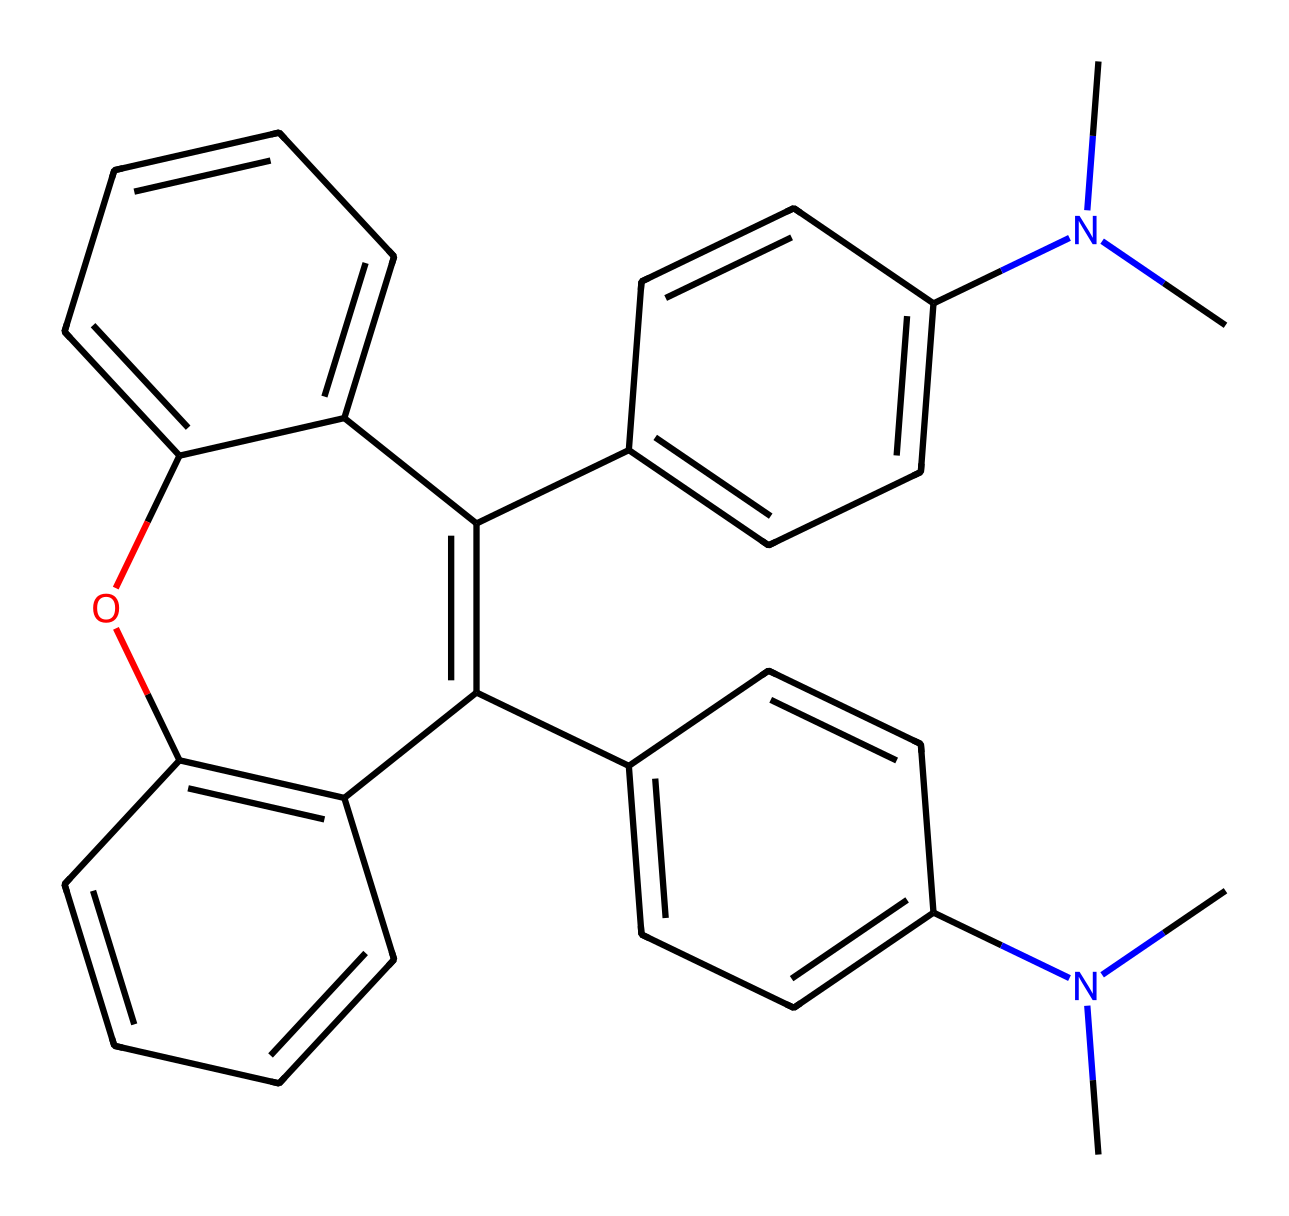What is the molecular formula represented by this SMILES? To find the molecular formula, count the number of each type of atom in the SMILES notation. Analyzing the structure reveals 24 carbon (C) atoms, 26 hydrogen (H) atoms, 2 nitrogen (N) atoms, and 1 oxygen (O) atom. Combining these counts gives us the molecular formula C24H26N2O.
Answer: C24H26N2O How many double bonds are present in this chemical? Evaluate the structure based on the presence of double bonds indicated by the "=" in the SMILES notation. There are 4 instances of double bonds observed in the detailed structure, leading to the conclusion that there are 4 double bonds in total.
Answer: 4 What type of functional group is present in this chemical? Analyze the chemical structure for recognizable functional groups. The presence of -N(CH3) groups indicates this is a tertiary amine. Additionally, the hydroxyl group (-OH) further confirms that this structure contains both an amine and an alcohol functional group.
Answer: amine, alcohol Which component contributes to the photochromic behavior of this compound? In photochromic compounds, certain structural features allow them to change color upon light exposure. Here, the aromatic rings and the presence of nitrogen atoms create resonance structures that can change during the process, facilitating color changes. Thus, the aromatic system contributes to this property.
Answer: aromatic rings What is the significance of nitrogen within this structure? The presence of nitrogen suggests this chemical can engage in electron donation, affecting the electronic and optical properties of the compound. Nitrogen atoms can also alter the energy levels of the molecular orbitals, making the compound suitable for photoresist applications due to its reactivity with light.
Answer: reactivity with light 